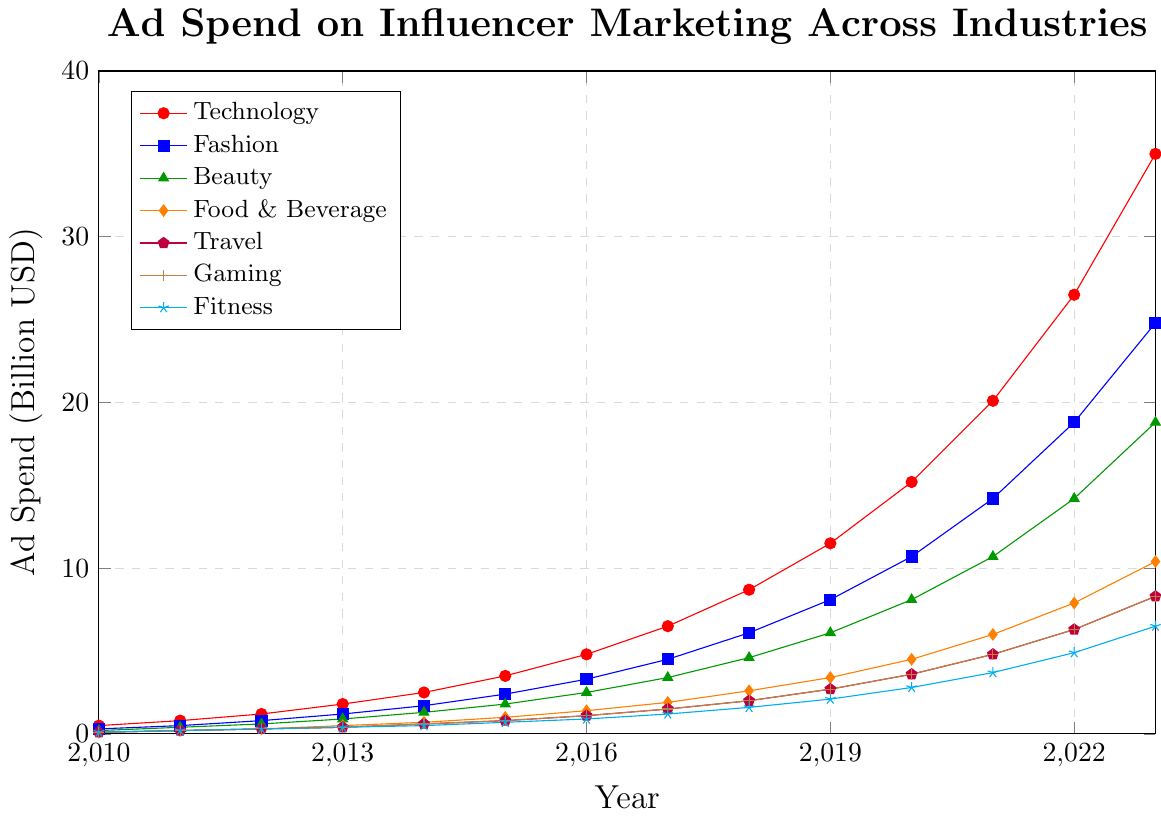What is the overall trend for ad spend in the Technology industry from 2010 to 2023? The ad spend in the Technology industry shows a consistently increasing trend from 2010 to 2023. It started at 0.5 billion USD in 2010 and reached 35.0 billion USD in 2023, indicating significant growth over the period.
Answer: Increasing trend Which industry had the smallest ad spend in 2016, and what was the amount? By looking at the lines in the chart for the year 2016, the Fitness industry had the smallest ad spend amounting to 0.9 billion USD.
Answer: Fitness, 0.9 billion USD What year did the Beauty industry surpass 10 billion USD in ad spend, and what was the exact amount that year? From the figure, the Beauty industry surpassed 10 billion USD in ad spend in 2021. The exact amount spent was 10.7 billion USD.
Answer: 2021, 10.7 billion USD Compare the rate of growth in ad spend between the Travel and Gaming industries from 2010 to 2023. To compare rates of growth, note that both industries started at 0.1 billion USD in 2010. By 2023, both have grown to 8.3 billion USD, indicating that they have identical growth rates over this period.
Answer: Identical growth rates In which year did the Food & Beverage industry's ad spend first exceed 5 billion USD, and by how much did it exceed? The Food & Beverage industry first exceeded 5 billion USD in ad spend in 2021. The amount was 6.0 billion USD, exceeding 5 billion by 1.0 billion USD.
Answer: 2021, 1.0 billion USD How much more was spent on influencer marketing in the Technology industry than in the Gaming industry in 2023? The ad spend in the Technology industry in 2023 was 35.0 billion USD, while in the Gaming industry, it was 8.3 billion USD. The difference is 35.0 - 8.3 = 26.7 billion USD.
Answer: 26.7 billion USD What is the combined ad spend for the Fashion and Beauty industries in 2019? In 2019, the ad spend for the Fashion industry was 8.1 billion USD, and for the Beauty industry, it was 6.1 billion USD. Combined, 8.1 + 6.1 = 14.2 billion USD.
Answer: 14.2 billion USD How did the ad spend in the Fitness industry in 2013 compare to that in 2010? The ad spend in the Fitness industry in 2013 was 0.4 billion USD, while in 2010, it was 0.1 billion USD, indicating an increase of 0.4 - 0.1 = 0.3 billion USD.
Answer: Increased by 0.3 billion USD 